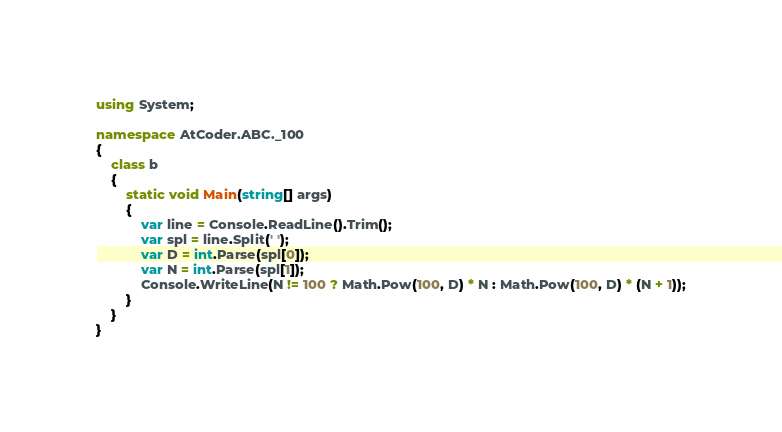<code> <loc_0><loc_0><loc_500><loc_500><_C#_>using System;

namespace AtCoder.ABC._100
{
    class b
    {
        static void Main(string[] args)
        {
            var line = Console.ReadLine().Trim();
            var spl = line.Split(' ');
            var D = int.Parse(spl[0]);
            var N = int.Parse(spl[1]);
            Console.WriteLine(N != 100 ? Math.Pow(100, D) * N : Math.Pow(100, D) * (N + 1));
        }
    }
}
</code> 